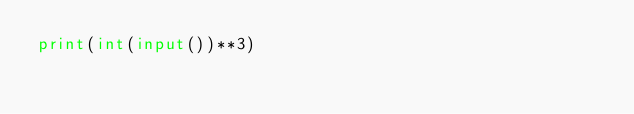<code> <loc_0><loc_0><loc_500><loc_500><_Python_>print(int(input())**3)</code> 